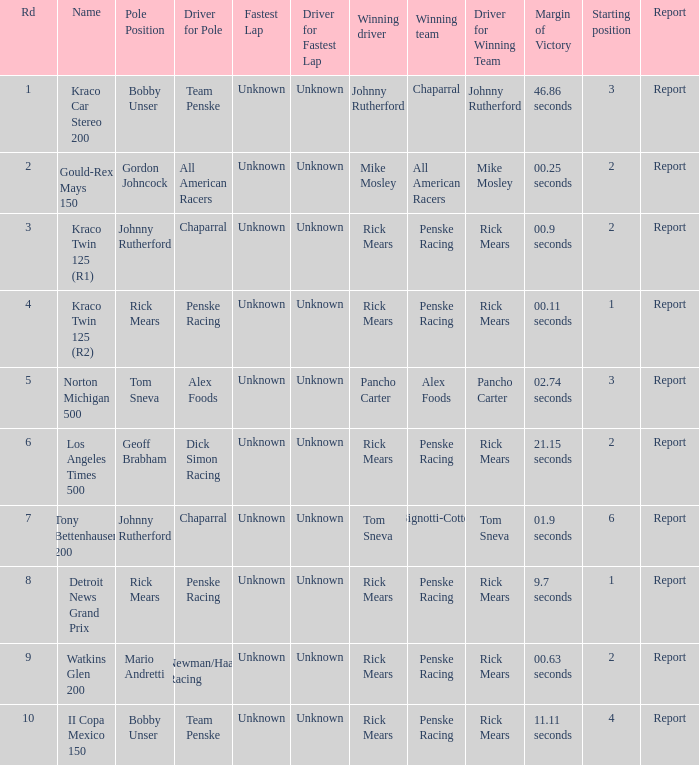The winning team of the race, los angeles times 500 is who? Penske Racing. 